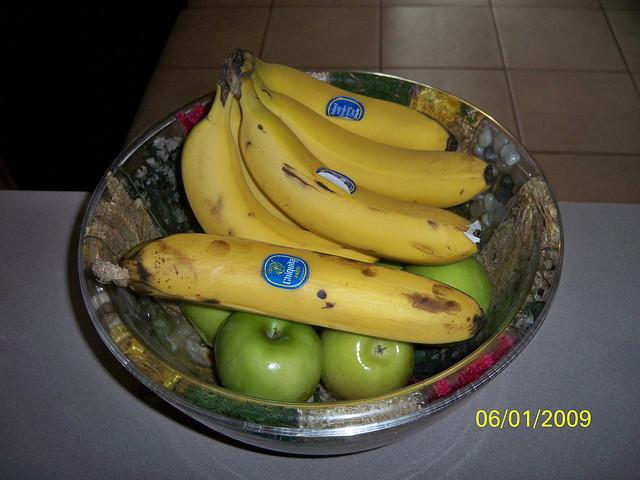How many bananas have stickers?
Be succinct. 3. Is this picture funny?
Write a very short answer. No. What fruit is in the bowl?
Be succinct. Bananas and apples. What color are apples?
Write a very short answer. Green. How many bananas?
Give a very brief answer. 6. 